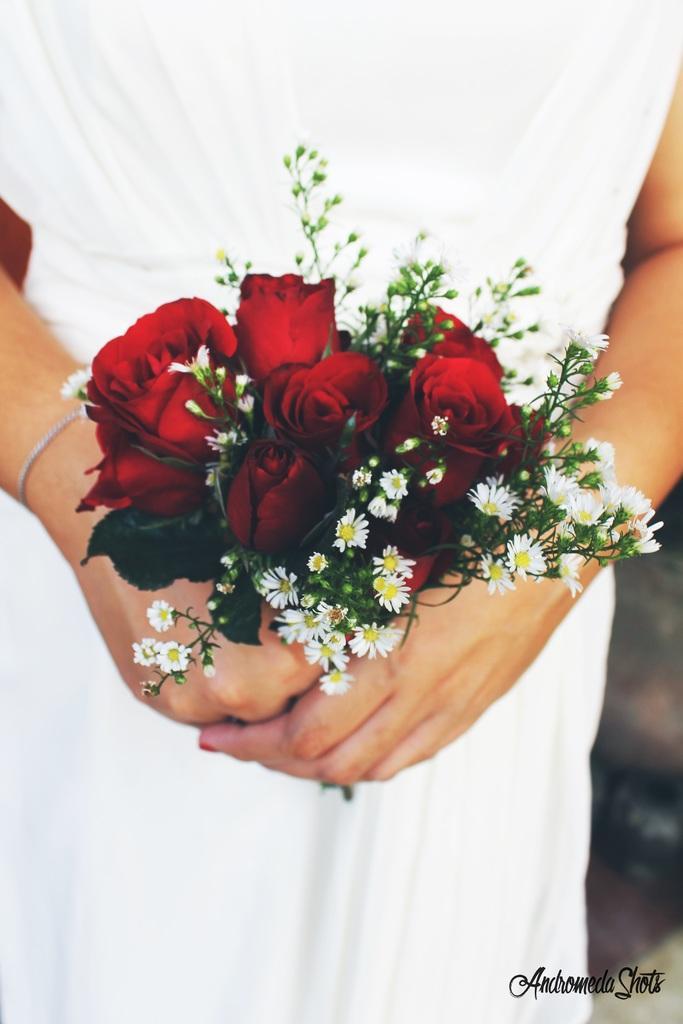Describe this image in one or two sentences. In this image, we can see a person holding a flower bouquet. On the right side bottom, there is a blur view and watermark in the image. 